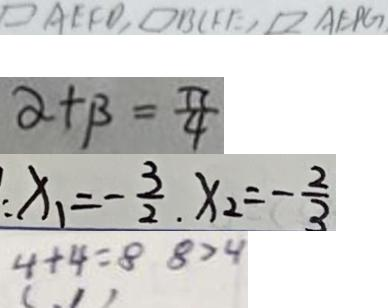<formula> <loc_0><loc_0><loc_500><loc_500>\square A E F D , \square B C F E , \square A E P G 
 \alpha + \beta = \frac { \pi } { 4 } 
 x _ { 1 } = - \frac { 3 } { 2 } , x _ { 2 } = - \frac { 2 } { 3 } 
 4 + 4 = 8 8 > 4</formula> 